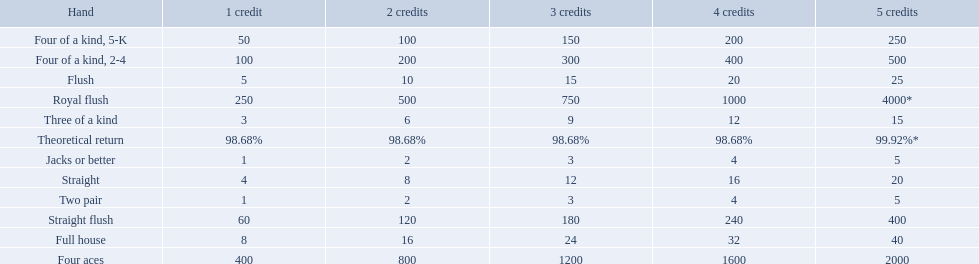What is the higher amount of points for one credit you can get from the best four of a kind 100. What type is it? Four of a kind, 2-4. Which hand is the third best hand in the card game super aces? Four aces. Which hand is the second best hand? Straight flush. Which hand had is the best hand? Royal flush. 